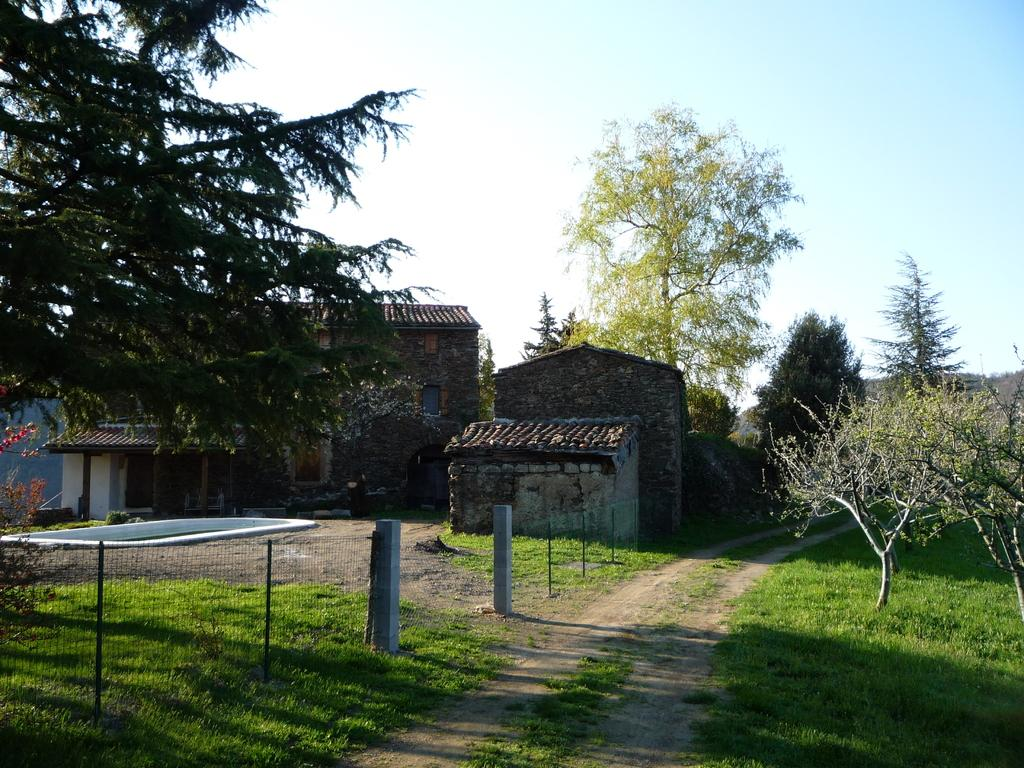What type of structures can be seen in the image? There are houses in the image. What type of vegetation is present in the image? There are trees in the image. What type of barrier can be seen in the image? There is fencing in the image. What type of ground cover is present in the image? There is grass in the image. What part of the natural environment is visible in the image? The sky is visible in the image. What type of nerve is present in the image? There is no nerve present in the image; the image features houses, trees, fencing, grass, and the sky. What type of development is taking place in the image? There is no development taking place in the image; it is a static scene featuring houses, trees, fencing, grass, and the sky. 